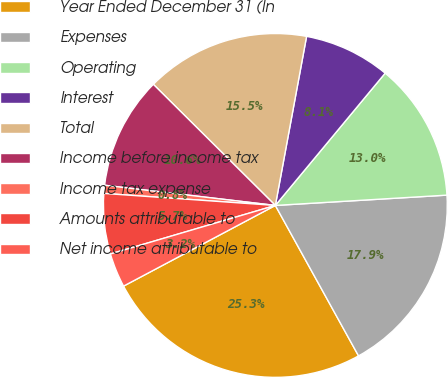Convert chart to OTSL. <chart><loc_0><loc_0><loc_500><loc_500><pie_chart><fcel>Year Ended December 31 (In<fcel>Expenses<fcel>Operating<fcel>Interest<fcel>Total<fcel>Income before income tax<fcel>Income tax expense<fcel>Amounts attributable to<fcel>Net income attributable to<nl><fcel>25.27%<fcel>17.92%<fcel>13.02%<fcel>8.12%<fcel>15.47%<fcel>10.57%<fcel>0.76%<fcel>5.67%<fcel>3.22%<nl></chart> 